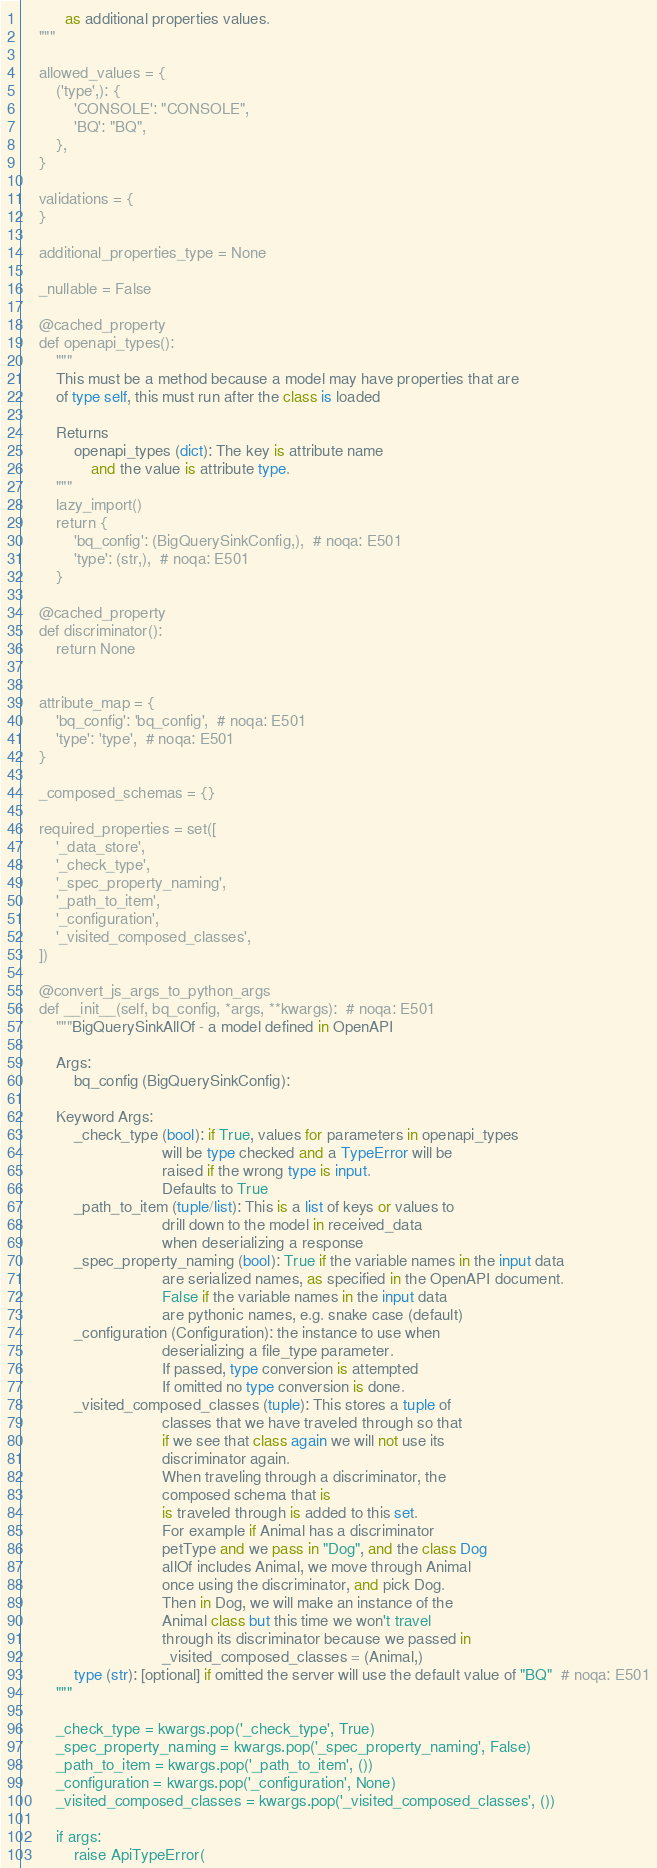Convert code to text. <code><loc_0><loc_0><loc_500><loc_500><_Python_>          as additional properties values.
    """

    allowed_values = {
        ('type',): {
            'CONSOLE': "CONSOLE",
            'BQ': "BQ",
        },
    }

    validations = {
    }

    additional_properties_type = None

    _nullable = False

    @cached_property
    def openapi_types():
        """
        This must be a method because a model may have properties that are
        of type self, this must run after the class is loaded

        Returns
            openapi_types (dict): The key is attribute name
                and the value is attribute type.
        """
        lazy_import()
        return {
            'bq_config': (BigQuerySinkConfig,),  # noqa: E501
            'type': (str,),  # noqa: E501
        }

    @cached_property
    def discriminator():
        return None


    attribute_map = {
        'bq_config': 'bq_config',  # noqa: E501
        'type': 'type',  # noqa: E501
    }

    _composed_schemas = {}

    required_properties = set([
        '_data_store',
        '_check_type',
        '_spec_property_naming',
        '_path_to_item',
        '_configuration',
        '_visited_composed_classes',
    ])

    @convert_js_args_to_python_args
    def __init__(self, bq_config, *args, **kwargs):  # noqa: E501
        """BigQuerySinkAllOf - a model defined in OpenAPI

        Args:
            bq_config (BigQuerySinkConfig):

        Keyword Args:
            _check_type (bool): if True, values for parameters in openapi_types
                                will be type checked and a TypeError will be
                                raised if the wrong type is input.
                                Defaults to True
            _path_to_item (tuple/list): This is a list of keys or values to
                                drill down to the model in received_data
                                when deserializing a response
            _spec_property_naming (bool): True if the variable names in the input data
                                are serialized names, as specified in the OpenAPI document.
                                False if the variable names in the input data
                                are pythonic names, e.g. snake case (default)
            _configuration (Configuration): the instance to use when
                                deserializing a file_type parameter.
                                If passed, type conversion is attempted
                                If omitted no type conversion is done.
            _visited_composed_classes (tuple): This stores a tuple of
                                classes that we have traveled through so that
                                if we see that class again we will not use its
                                discriminator again.
                                When traveling through a discriminator, the
                                composed schema that is
                                is traveled through is added to this set.
                                For example if Animal has a discriminator
                                petType and we pass in "Dog", and the class Dog
                                allOf includes Animal, we move through Animal
                                once using the discriminator, and pick Dog.
                                Then in Dog, we will make an instance of the
                                Animal class but this time we won't travel
                                through its discriminator because we passed in
                                _visited_composed_classes = (Animal,)
            type (str): [optional] if omitted the server will use the default value of "BQ"  # noqa: E501
        """

        _check_type = kwargs.pop('_check_type', True)
        _spec_property_naming = kwargs.pop('_spec_property_naming', False)
        _path_to_item = kwargs.pop('_path_to_item', ())
        _configuration = kwargs.pop('_configuration', None)
        _visited_composed_classes = kwargs.pop('_visited_composed_classes', ())

        if args:
            raise ApiTypeError(</code> 